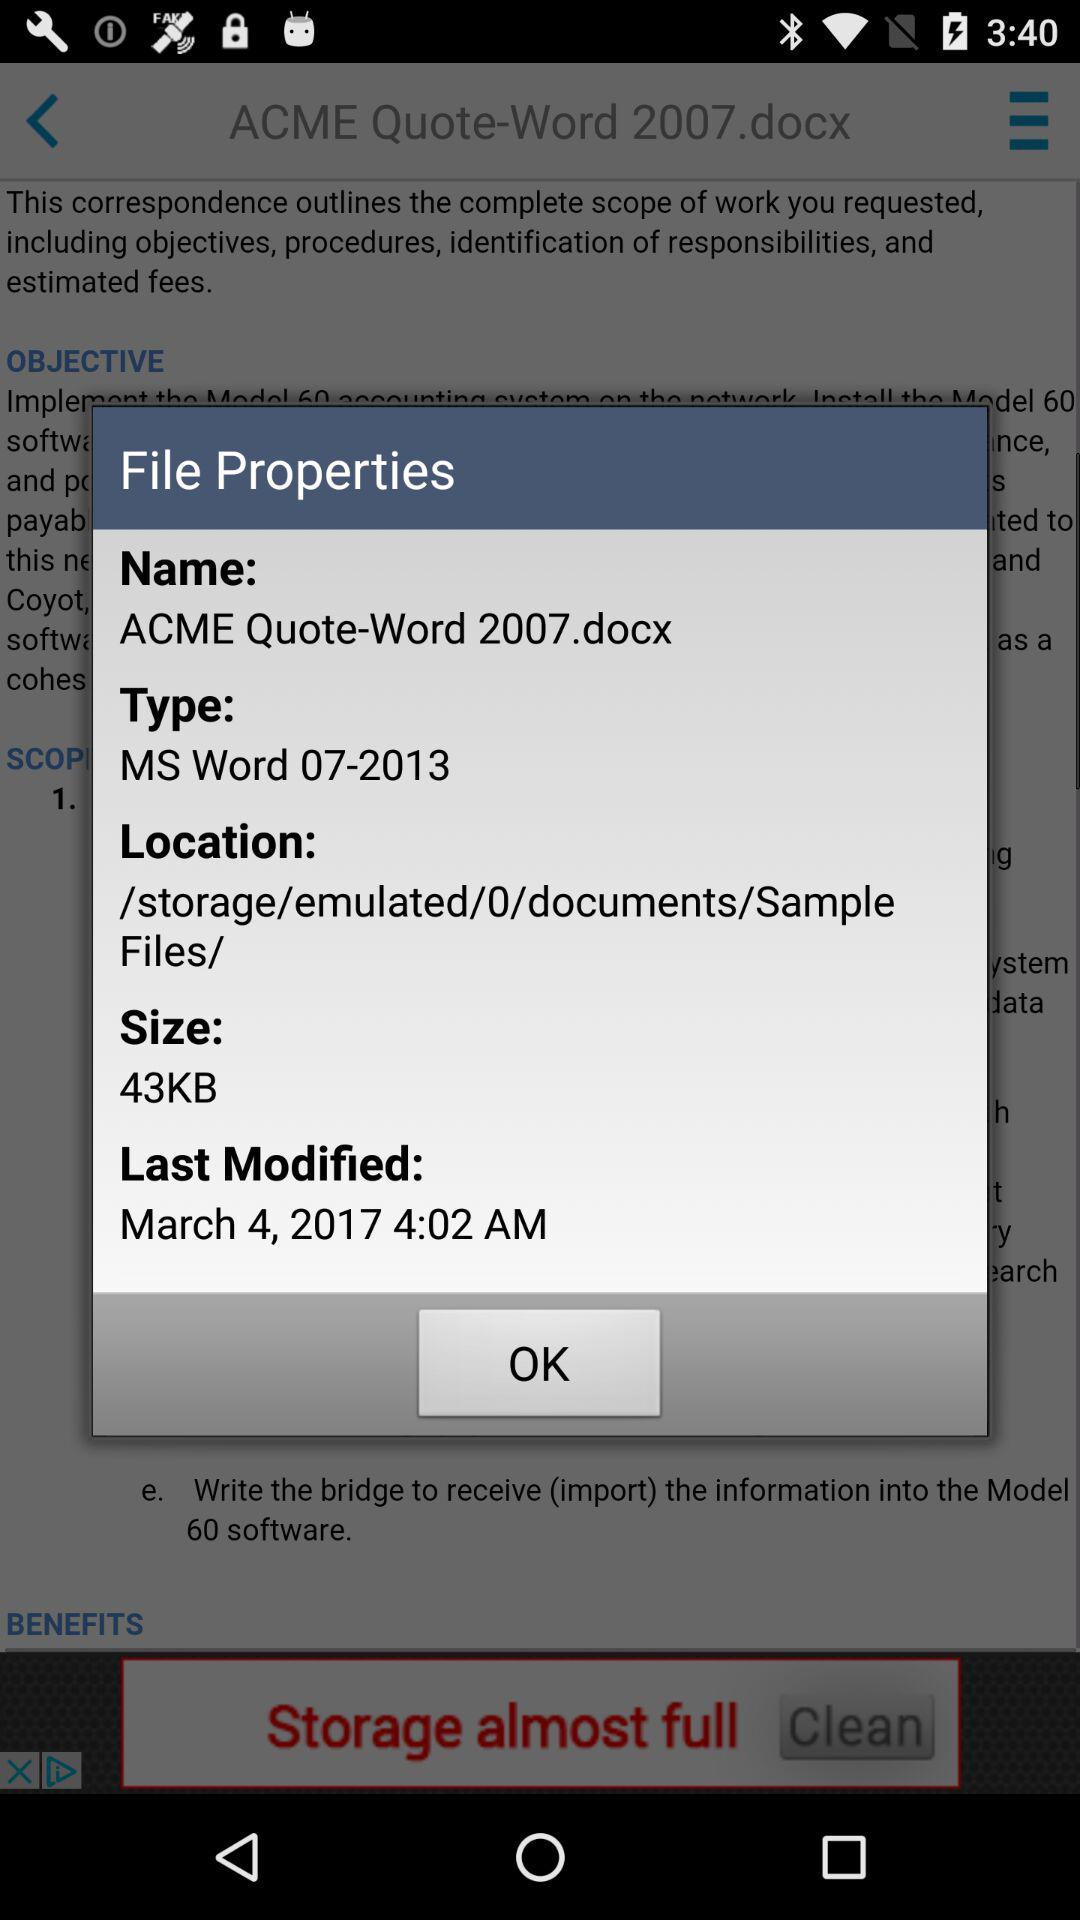What is the "Last Modified" date? The "Last Modified" date is March 4, 2017. 